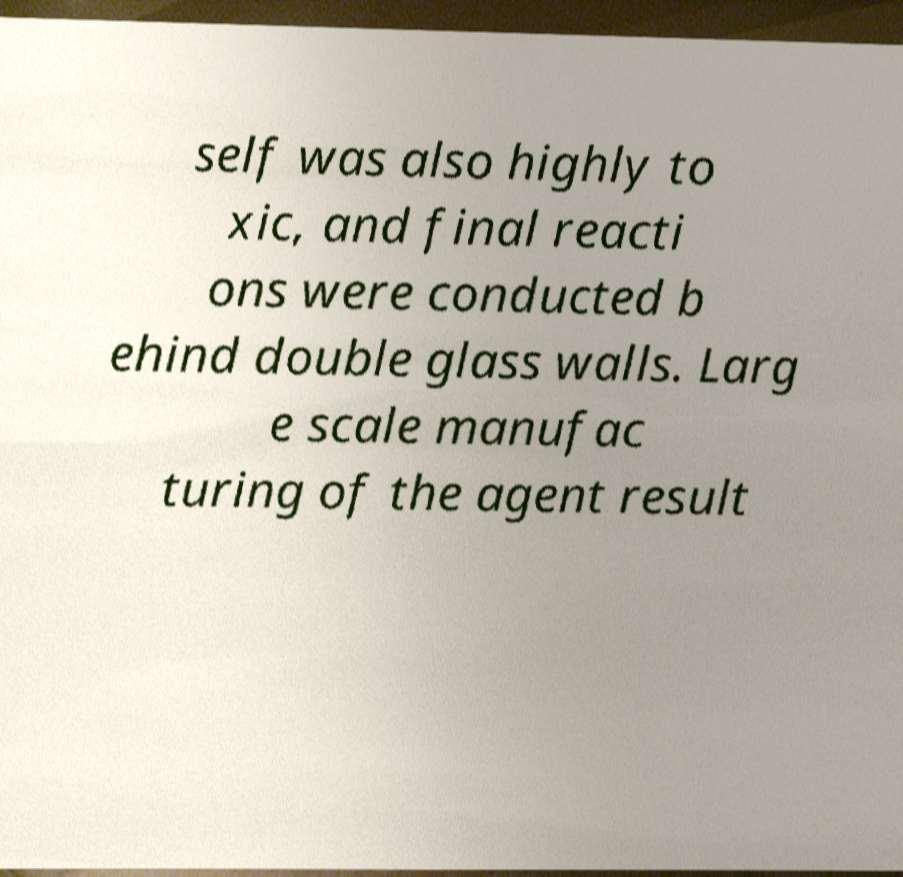Can you accurately transcribe the text from the provided image for me? self was also highly to xic, and final reacti ons were conducted b ehind double glass walls. Larg e scale manufac turing of the agent result 